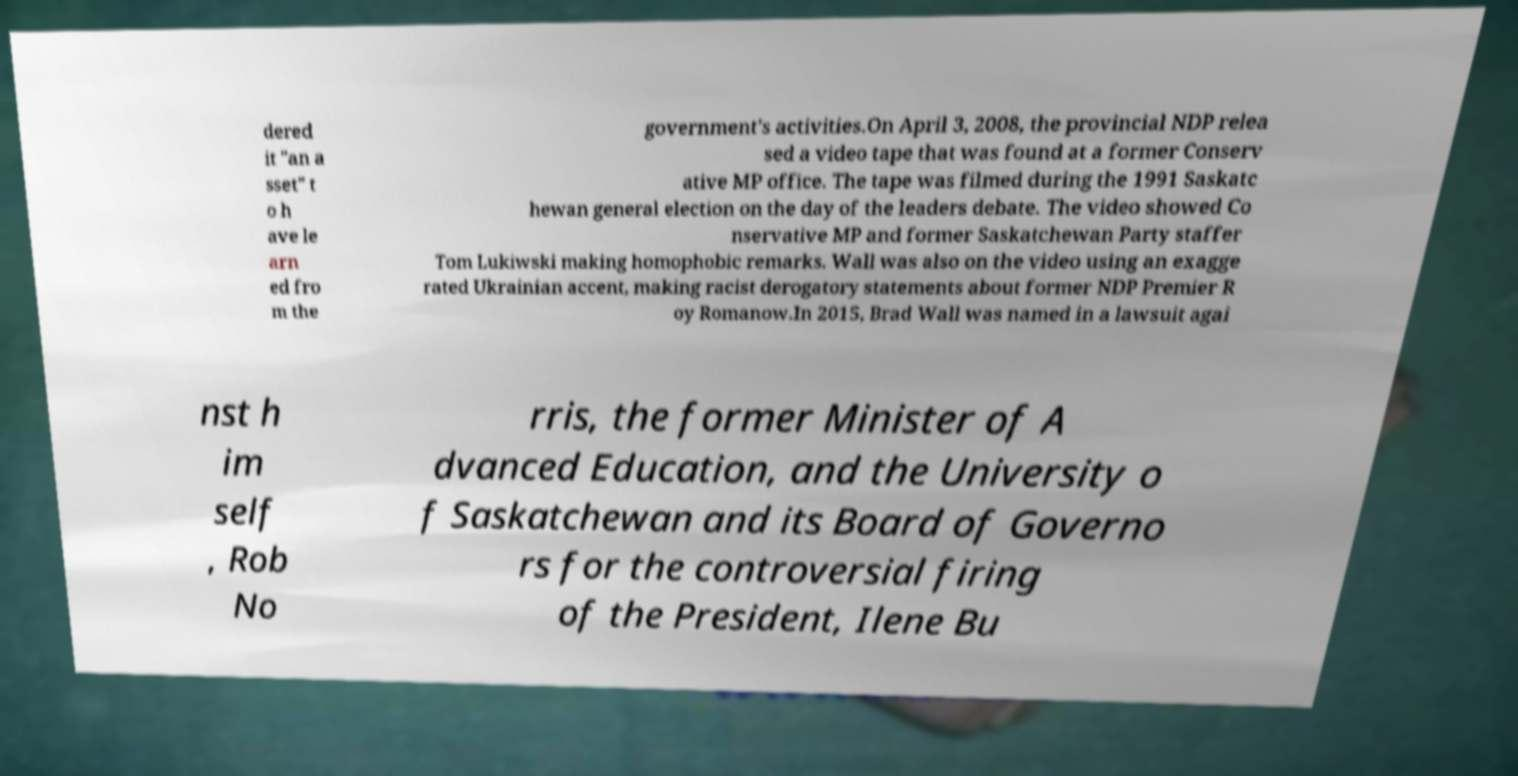Could you assist in decoding the text presented in this image and type it out clearly? dered it "an a sset" t o h ave le arn ed fro m the government's activities.On April 3, 2008, the provincial NDP relea sed a video tape that was found at a former Conserv ative MP office. The tape was filmed during the 1991 Saskatc hewan general election on the day of the leaders debate. The video showed Co nservative MP and former Saskatchewan Party staffer Tom Lukiwski making homophobic remarks. Wall was also on the video using an exagge rated Ukrainian accent, making racist derogatory statements about former NDP Premier R oy Romanow.In 2015, Brad Wall was named in a lawsuit agai nst h im self , Rob No rris, the former Minister of A dvanced Education, and the University o f Saskatchewan and its Board of Governo rs for the controversial firing of the President, Ilene Bu 